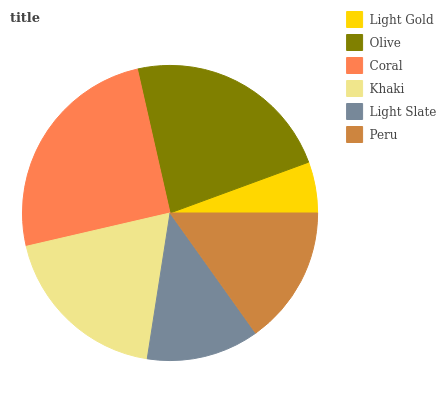Is Light Gold the minimum?
Answer yes or no. Yes. Is Coral the maximum?
Answer yes or no. Yes. Is Olive the minimum?
Answer yes or no. No. Is Olive the maximum?
Answer yes or no. No. Is Olive greater than Light Gold?
Answer yes or no. Yes. Is Light Gold less than Olive?
Answer yes or no. Yes. Is Light Gold greater than Olive?
Answer yes or no. No. Is Olive less than Light Gold?
Answer yes or no. No. Is Khaki the high median?
Answer yes or no. Yes. Is Peru the low median?
Answer yes or no. Yes. Is Light Gold the high median?
Answer yes or no. No. Is Khaki the low median?
Answer yes or no. No. 